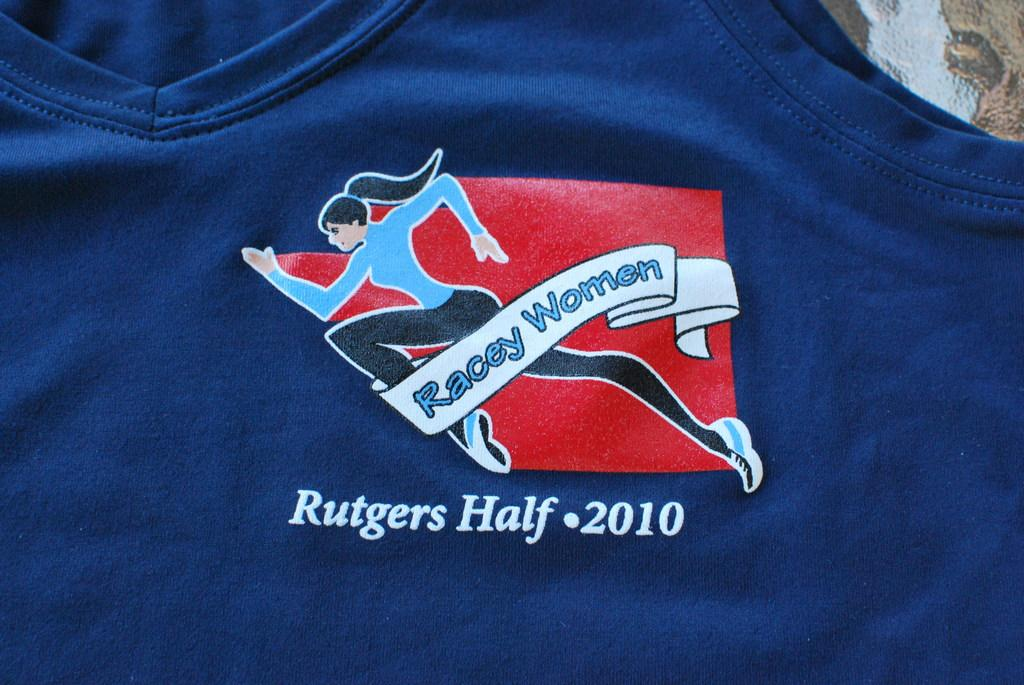<image>
Offer a succinct explanation of the picture presented. a flag that has Rutgers Half written on it 